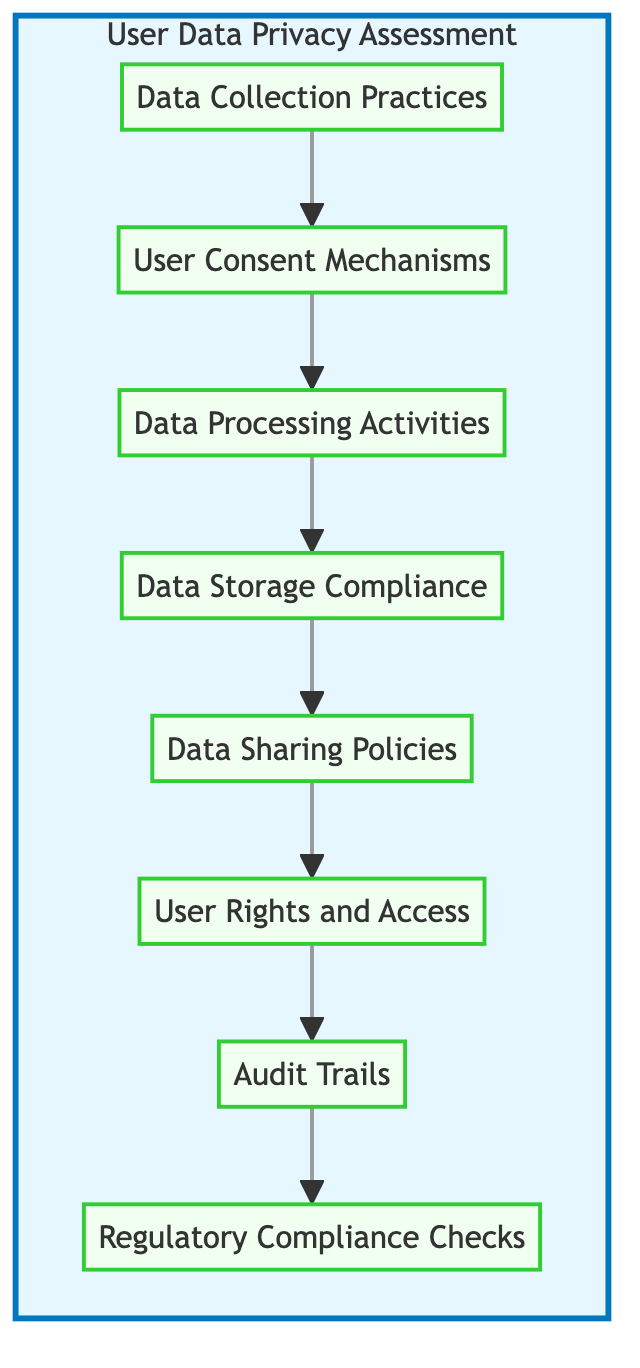What is the first step in the user data privacy assessment process? The first step is "Data Collection Practices," which is the starting node in the flow chart representing the first stage of evaluating user data handling.
Answer: Data Collection Practices How many total steps are illustrated in the diagram? There are eight steps in the diagram, listed from "Data Collection Practices" down to "Regulatory Compliance Checks."
Answer: Eight What comes after "User Consent Mechanisms" in the flow chart? The step that follows "User Consent Mechanisms" is "Data Processing Activities," indicating the progression from obtaining consent to processing the data.
Answer: Data Processing Activities What is the last node in the flow chart? The last node in the flow chart is "Regulatory Compliance Checks," which signifies the final assessment step regarding legal compliance related to user data.
Answer: Regulatory Compliance Checks Which practice assesses how user data is processed? The practice that assesses how user data is processed is "Data Processing Activities," which evaluates what happens to data after collection and consent.
Answer: Data Processing Activities How does "User Rights and Access" relate to "Audit Trails"? "User Rights and Access" leads into "Audit Trails," emphasizing that users' rights must be traceable and logged to ensure transparency and accountability in data interactions.
Answer: Leads into What is the purpose of reviewing "Audit Trails"? The purpose of reviewing "Audit Trails" is to ensure accountability and traceability of user data interactions, allowing oversight of how data is handled throughout its lifecycle.
Answer: Accountability and traceability Which step involves analyzing third-party data sharing practices? The step that involves analyzing third-party data sharing practices is "Data Sharing Policies," which looks at partnerships and external service providers that handle user data.
Answer: Data Sharing Policies What is the role of "Regulatory Compliance Checks" in the assessment process? The role of "Regulatory Compliance Checks" is to ensure adherence to relevant regulations such as GDPR, CCPA, or HIPAA, which is crucial for legal compliance in user data handling practices.
Answer: Ensure adherence to regulations 